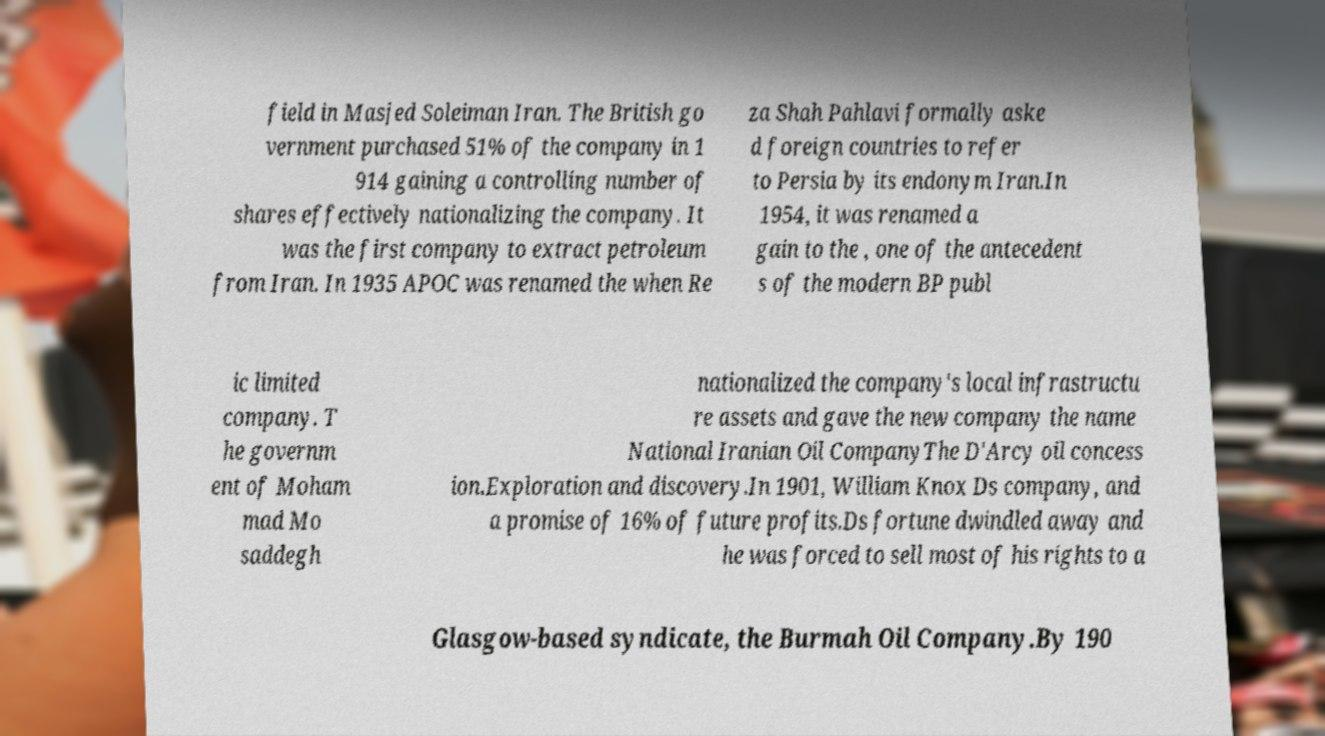Please read and relay the text visible in this image. What does it say? field in Masjed Soleiman Iran. The British go vernment purchased 51% of the company in 1 914 gaining a controlling number of shares effectively nationalizing the company. It was the first company to extract petroleum from Iran. In 1935 APOC was renamed the when Re za Shah Pahlavi formally aske d foreign countries to refer to Persia by its endonym Iran.In 1954, it was renamed a gain to the , one of the antecedent s of the modern BP publ ic limited company. T he governm ent of Moham mad Mo saddegh nationalized the company's local infrastructu re assets and gave the new company the name National Iranian Oil CompanyThe D'Arcy oil concess ion.Exploration and discovery.In 1901, William Knox Ds company, and a promise of 16% of future profits.Ds fortune dwindled away and he was forced to sell most of his rights to a Glasgow-based syndicate, the Burmah Oil Company.By 190 